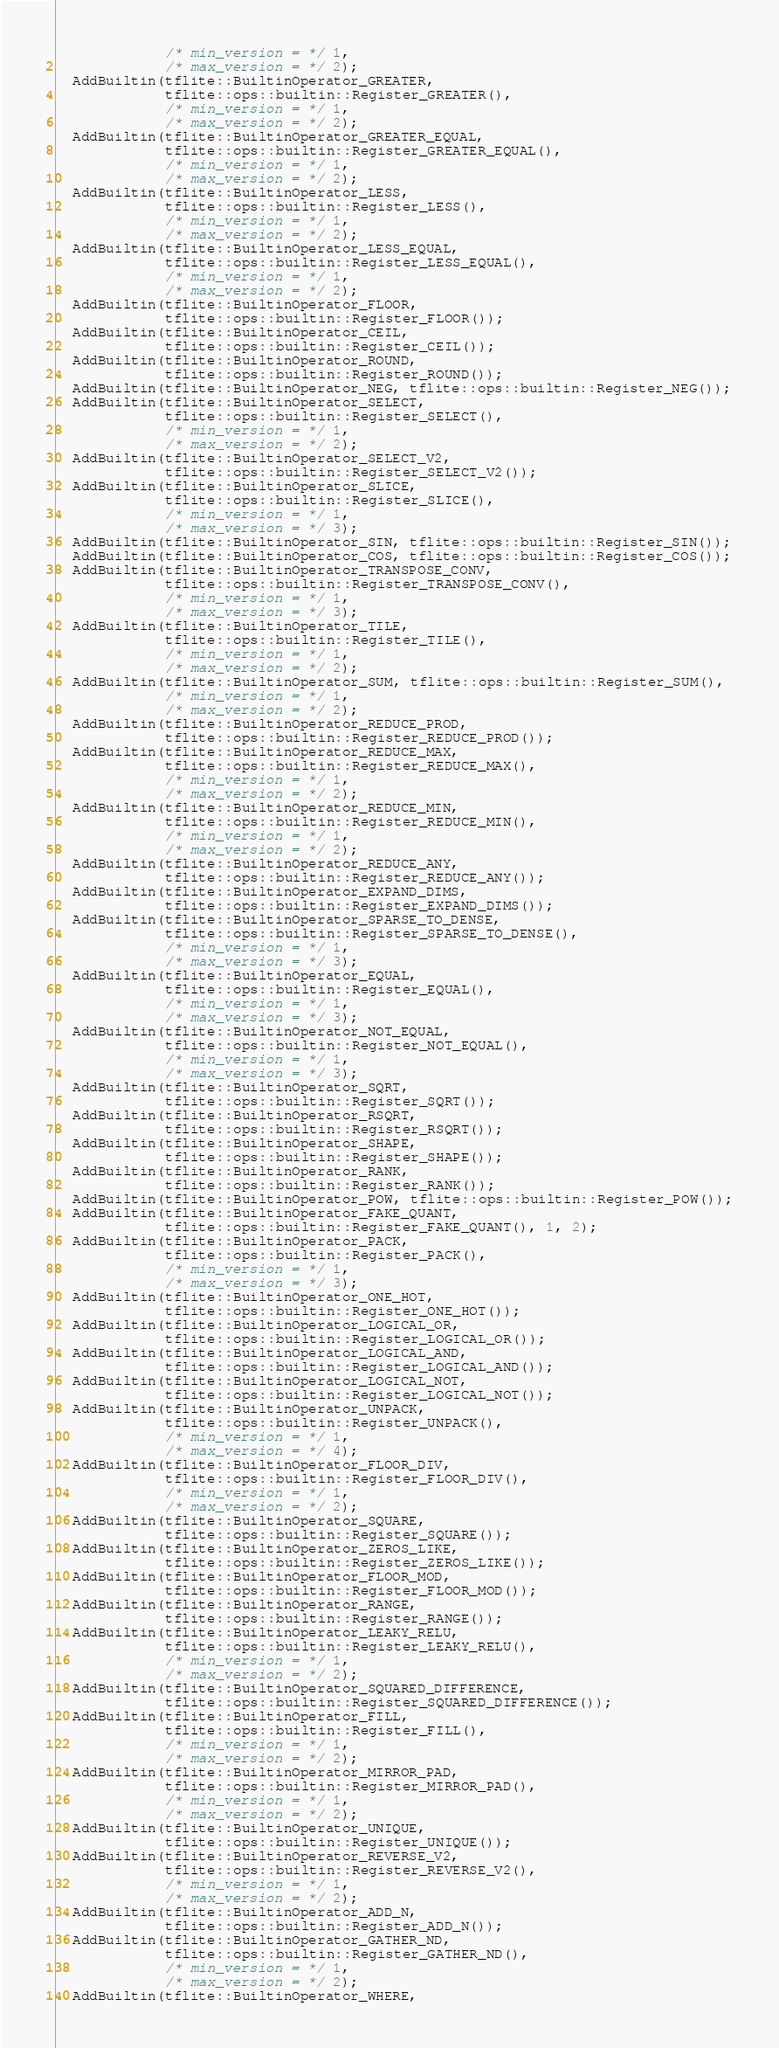<code> <loc_0><loc_0><loc_500><loc_500><_C++_>             /* min_version = */ 1,
             /* max_version = */ 2);
  AddBuiltin(tflite::BuiltinOperator_GREATER,
             tflite::ops::builtin::Register_GREATER(),
             /* min_version = */ 1,
             /* max_version = */ 2);
  AddBuiltin(tflite::BuiltinOperator_GREATER_EQUAL,
             tflite::ops::builtin::Register_GREATER_EQUAL(),
             /* min_version = */ 1,
             /* max_version = */ 2);
  AddBuiltin(tflite::BuiltinOperator_LESS,
             tflite::ops::builtin::Register_LESS(),
             /* min_version = */ 1,
             /* max_version = */ 2);
  AddBuiltin(tflite::BuiltinOperator_LESS_EQUAL,
             tflite::ops::builtin::Register_LESS_EQUAL(),
             /* min_version = */ 1,
             /* max_version = */ 2);
  AddBuiltin(tflite::BuiltinOperator_FLOOR,
             tflite::ops::builtin::Register_FLOOR());
  AddBuiltin(tflite::BuiltinOperator_CEIL,
             tflite::ops::builtin::Register_CEIL());
  AddBuiltin(tflite::BuiltinOperator_ROUND,
             tflite::ops::builtin::Register_ROUND());
  AddBuiltin(tflite::BuiltinOperator_NEG, tflite::ops::builtin::Register_NEG());
  AddBuiltin(tflite::BuiltinOperator_SELECT,
             tflite::ops::builtin::Register_SELECT(),
             /* min_version = */ 1,
             /* max_version = */ 2);
  AddBuiltin(tflite::BuiltinOperator_SELECT_V2,
             tflite::ops::builtin::Register_SELECT_V2());
  AddBuiltin(tflite::BuiltinOperator_SLICE,
             tflite::ops::builtin::Register_SLICE(),
             /* min_version = */ 1,
             /* max_version = */ 3);
  AddBuiltin(tflite::BuiltinOperator_SIN, tflite::ops::builtin::Register_SIN());
  AddBuiltin(tflite::BuiltinOperator_COS, tflite::ops::builtin::Register_COS());
  AddBuiltin(tflite::BuiltinOperator_TRANSPOSE_CONV,
             tflite::ops::builtin::Register_TRANSPOSE_CONV(),
             /* min_version = */ 1,
             /* max_version = */ 3);
  AddBuiltin(tflite::BuiltinOperator_TILE,
             tflite::ops::builtin::Register_TILE(),
             /* min_version = */ 1,
             /* max_version = */ 2);
  AddBuiltin(tflite::BuiltinOperator_SUM, tflite::ops::builtin::Register_SUM(),
             /* min_version = */ 1,
             /* max_version = */ 2);
  AddBuiltin(tflite::BuiltinOperator_REDUCE_PROD,
             tflite::ops::builtin::Register_REDUCE_PROD());
  AddBuiltin(tflite::BuiltinOperator_REDUCE_MAX,
             tflite::ops::builtin::Register_REDUCE_MAX(),
             /* min_version = */ 1,
             /* max_version = */ 2);
  AddBuiltin(tflite::BuiltinOperator_REDUCE_MIN,
             tflite::ops::builtin::Register_REDUCE_MIN(),
             /* min_version = */ 1,
             /* max_version = */ 2);
  AddBuiltin(tflite::BuiltinOperator_REDUCE_ANY,
             tflite::ops::builtin::Register_REDUCE_ANY());
  AddBuiltin(tflite::BuiltinOperator_EXPAND_DIMS,
             tflite::ops::builtin::Register_EXPAND_DIMS());
  AddBuiltin(tflite::BuiltinOperator_SPARSE_TO_DENSE,
             tflite::ops::builtin::Register_SPARSE_TO_DENSE(),
             /* min_version = */ 1,
             /* max_version = */ 3);
  AddBuiltin(tflite::BuiltinOperator_EQUAL,
             tflite::ops::builtin::Register_EQUAL(),
             /* min_version = */ 1,
             /* max_version = */ 3);
  AddBuiltin(tflite::BuiltinOperator_NOT_EQUAL,
             tflite::ops::builtin::Register_NOT_EQUAL(),
             /* min_version = */ 1,
             /* max_version = */ 3);
  AddBuiltin(tflite::BuiltinOperator_SQRT,
             tflite::ops::builtin::Register_SQRT());
  AddBuiltin(tflite::BuiltinOperator_RSQRT,
             tflite::ops::builtin::Register_RSQRT());
  AddBuiltin(tflite::BuiltinOperator_SHAPE,
             tflite::ops::builtin::Register_SHAPE());
  AddBuiltin(tflite::BuiltinOperator_RANK,
             tflite::ops::builtin::Register_RANK());
  AddBuiltin(tflite::BuiltinOperator_POW, tflite::ops::builtin::Register_POW());
  AddBuiltin(tflite::BuiltinOperator_FAKE_QUANT,
             tflite::ops::builtin::Register_FAKE_QUANT(), 1, 2);
  AddBuiltin(tflite::BuiltinOperator_PACK,
             tflite::ops::builtin::Register_PACK(),
             /* min_version = */ 1,
             /* max_version = */ 3);
  AddBuiltin(tflite::BuiltinOperator_ONE_HOT,
             tflite::ops::builtin::Register_ONE_HOT());
  AddBuiltin(tflite::BuiltinOperator_LOGICAL_OR,
             tflite::ops::builtin::Register_LOGICAL_OR());
  AddBuiltin(tflite::BuiltinOperator_LOGICAL_AND,
             tflite::ops::builtin::Register_LOGICAL_AND());
  AddBuiltin(tflite::BuiltinOperator_LOGICAL_NOT,
             tflite::ops::builtin::Register_LOGICAL_NOT());
  AddBuiltin(tflite::BuiltinOperator_UNPACK,
             tflite::ops::builtin::Register_UNPACK(),
             /* min_version = */ 1,
             /* max_version = */ 4);
  AddBuiltin(tflite::BuiltinOperator_FLOOR_DIV,
             tflite::ops::builtin::Register_FLOOR_DIV(),
             /* min_version = */ 1,
             /* max_version = */ 2);
  AddBuiltin(tflite::BuiltinOperator_SQUARE,
             tflite::ops::builtin::Register_SQUARE());
  AddBuiltin(tflite::BuiltinOperator_ZEROS_LIKE,
             tflite::ops::builtin::Register_ZEROS_LIKE());
  AddBuiltin(tflite::BuiltinOperator_FLOOR_MOD,
             tflite::ops::builtin::Register_FLOOR_MOD());
  AddBuiltin(tflite::BuiltinOperator_RANGE,
             tflite::ops::builtin::Register_RANGE());
  AddBuiltin(tflite::BuiltinOperator_LEAKY_RELU,
             tflite::ops::builtin::Register_LEAKY_RELU(),
             /* min_version = */ 1,
             /* max_version = */ 2);
  AddBuiltin(tflite::BuiltinOperator_SQUARED_DIFFERENCE,
             tflite::ops::builtin::Register_SQUARED_DIFFERENCE());
  AddBuiltin(tflite::BuiltinOperator_FILL,
             tflite::ops::builtin::Register_FILL(),
             /* min_version = */ 1,
             /* max_version = */ 2);
  AddBuiltin(tflite::BuiltinOperator_MIRROR_PAD,
             tflite::ops::builtin::Register_MIRROR_PAD(),
             /* min_version = */ 1,
             /* max_version = */ 2);
  AddBuiltin(tflite::BuiltinOperator_UNIQUE,
             tflite::ops::builtin::Register_UNIQUE());
  AddBuiltin(tflite::BuiltinOperator_REVERSE_V2,
             tflite::ops::builtin::Register_REVERSE_V2(),
             /* min_version = */ 1,
             /* max_version = */ 2);
  AddBuiltin(tflite::BuiltinOperator_ADD_N,
             tflite::ops::builtin::Register_ADD_N());
  AddBuiltin(tflite::BuiltinOperator_GATHER_ND,
             tflite::ops::builtin::Register_GATHER_ND(),
             /* min_version = */ 1,
             /* max_version = */ 2);
  AddBuiltin(tflite::BuiltinOperator_WHERE,</code> 